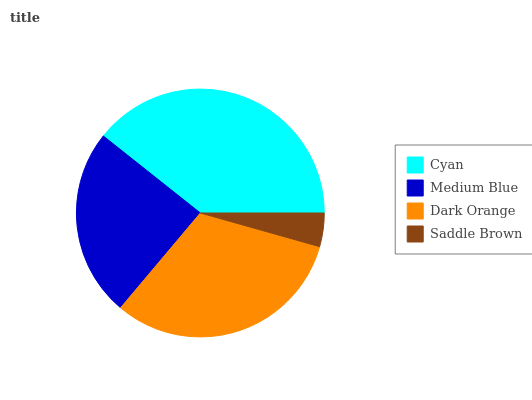Is Saddle Brown the minimum?
Answer yes or no. Yes. Is Cyan the maximum?
Answer yes or no. Yes. Is Medium Blue the minimum?
Answer yes or no. No. Is Medium Blue the maximum?
Answer yes or no. No. Is Cyan greater than Medium Blue?
Answer yes or no. Yes. Is Medium Blue less than Cyan?
Answer yes or no. Yes. Is Medium Blue greater than Cyan?
Answer yes or no. No. Is Cyan less than Medium Blue?
Answer yes or no. No. Is Dark Orange the high median?
Answer yes or no. Yes. Is Medium Blue the low median?
Answer yes or no. Yes. Is Medium Blue the high median?
Answer yes or no. No. Is Cyan the low median?
Answer yes or no. No. 